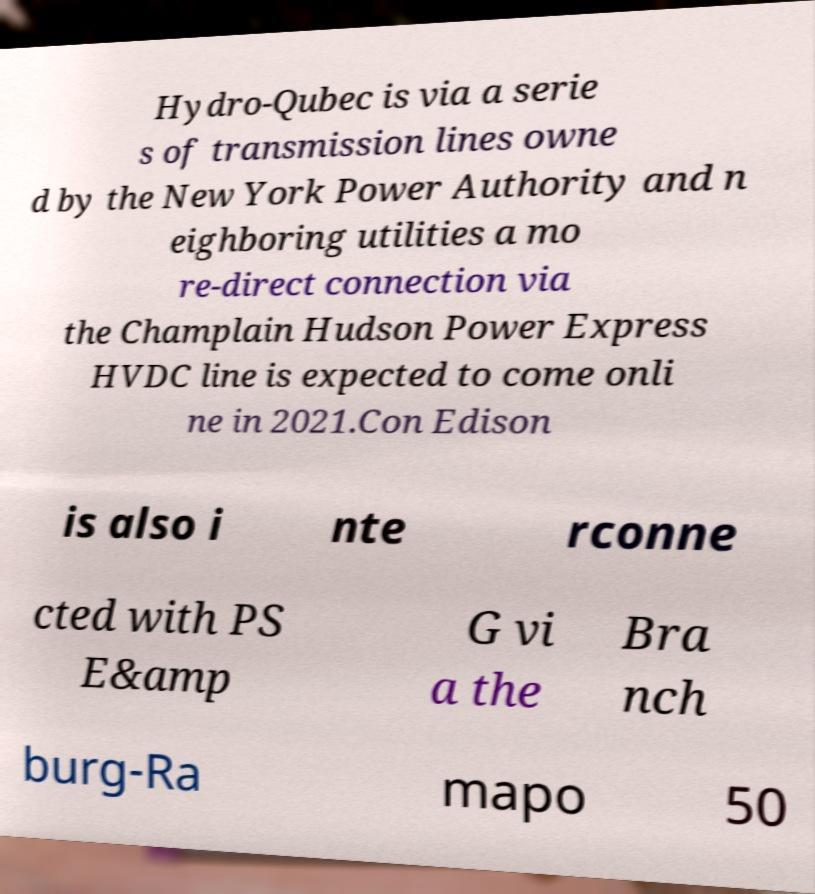Can you read and provide the text displayed in the image?This photo seems to have some interesting text. Can you extract and type it out for me? Hydro-Qubec is via a serie s of transmission lines owne d by the New York Power Authority and n eighboring utilities a mo re-direct connection via the Champlain Hudson Power Express HVDC line is expected to come onli ne in 2021.Con Edison is also i nte rconne cted with PS E&amp G vi a the Bra nch burg-Ra mapo 50 